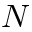<formula> <loc_0><loc_0><loc_500><loc_500>N</formula> 